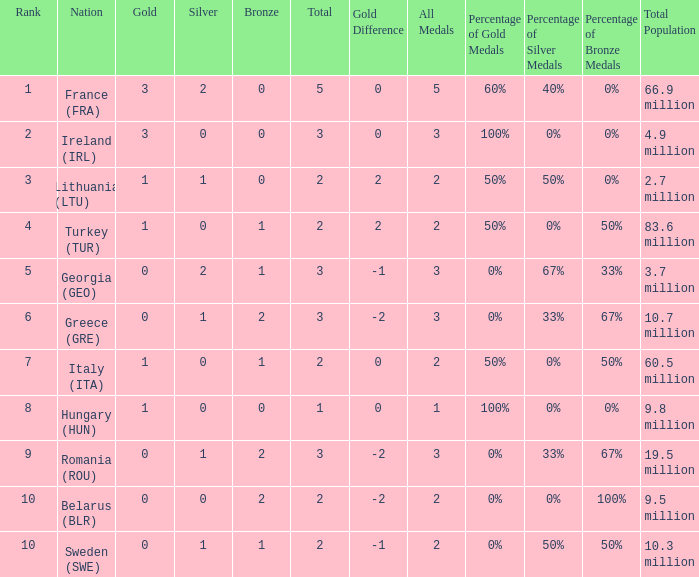What are the most bronze medals in a rank more than 1 with a total larger than 3? None. 